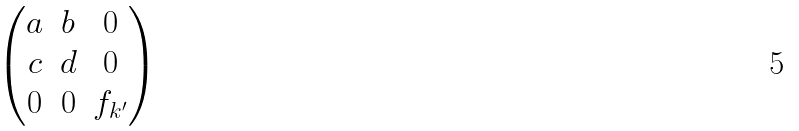<formula> <loc_0><loc_0><loc_500><loc_500>\begin{pmatrix} a & b & 0 \\ c & d & 0 \\ 0 & 0 & f _ { k ^ { \prime } } \end{pmatrix}</formula> 